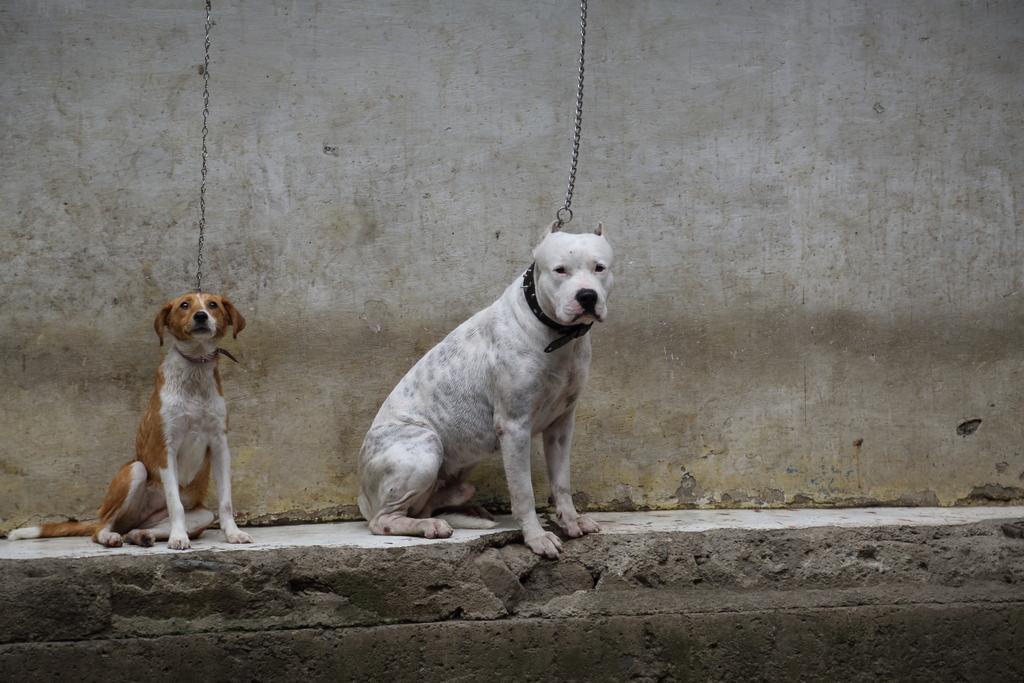How many dogs are present in the image? There are two dogs in the image. What are the dogs doing in the image? The dogs are sitting on a platform. Are the dogs restrained in any way? Yes, the dogs have chains. What can be seen in the background of the image? There is a wall in the background of the image. What type of zinc is being used to create shade for the dogs in the image? There is no zinc or shade present in the image; the dogs are sitting on a platform with chains. Is there any smoke visible in the image? There is no smoke visible in the image. 